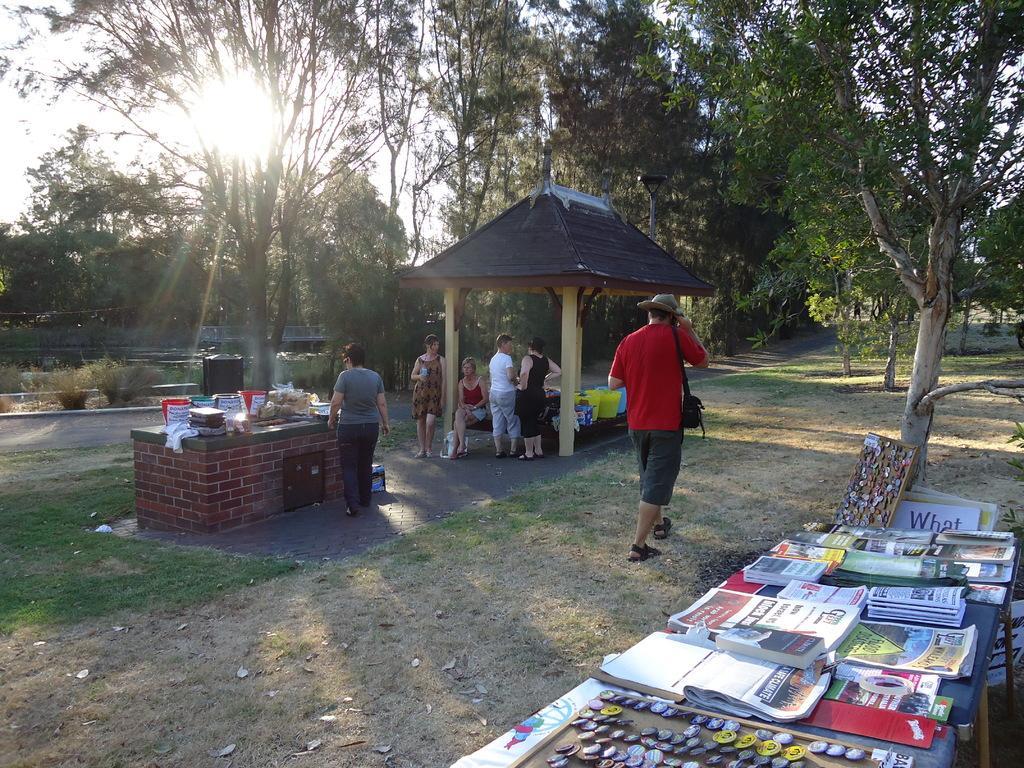In one or two sentences, can you explain what this image depicts? In this picture we can see books, badges on tables, buckets, plastic covers, shed and a man carrying a bag and walking on the ground and some people and some objects and in the background we can see trees, plants and the sky. 